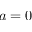Convert formula to latex. <formula><loc_0><loc_0><loc_500><loc_500>a = 0</formula> 